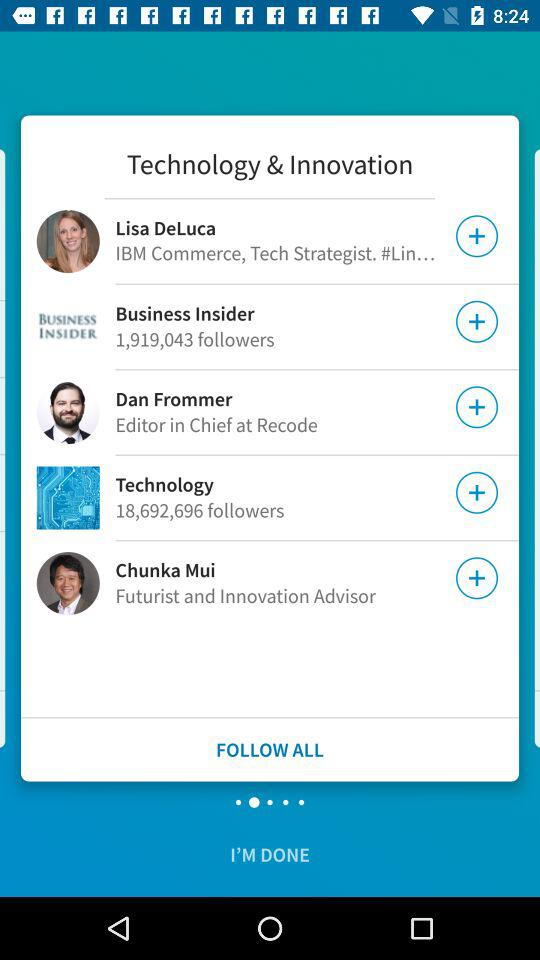How many people are following Technology?
Answer the question using a single word or phrase. 18,692,696 